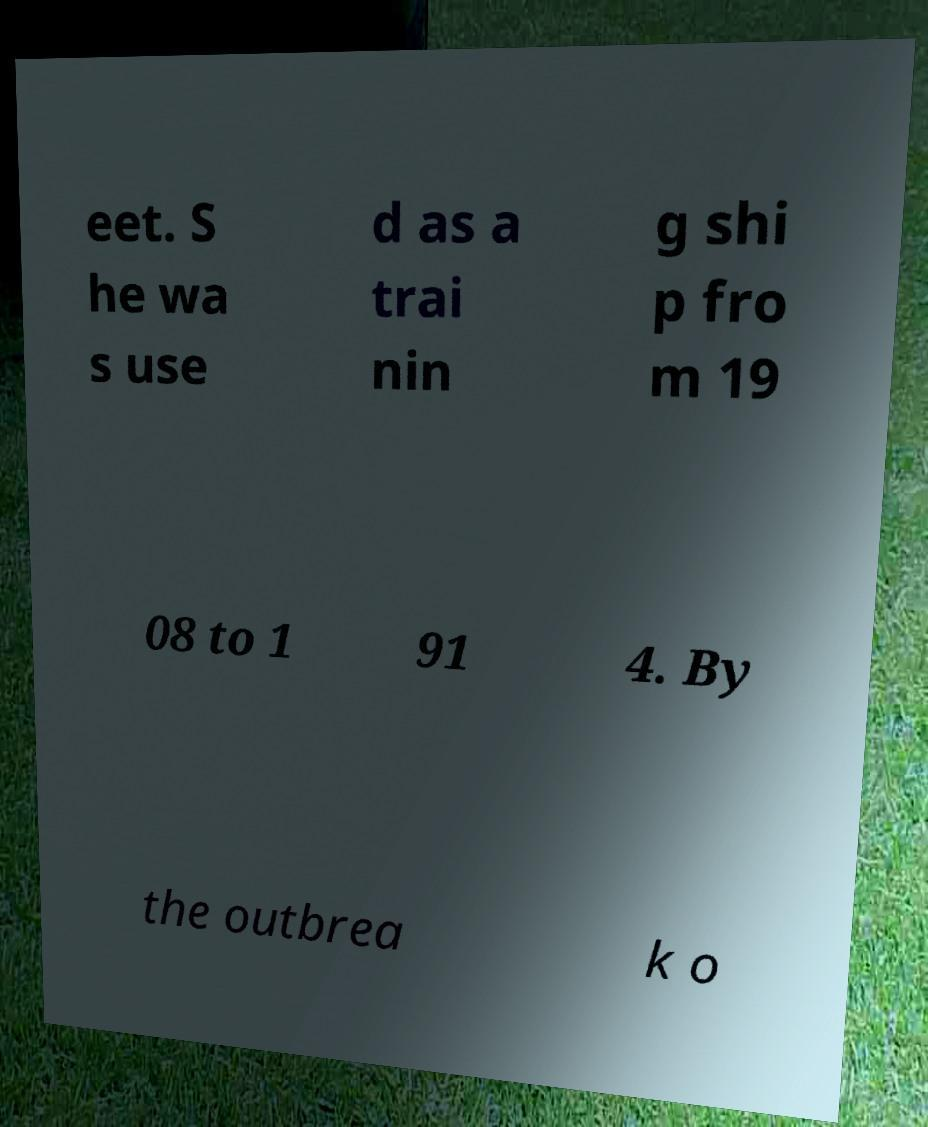Could you assist in decoding the text presented in this image and type it out clearly? eet. S he wa s use d as a trai nin g shi p fro m 19 08 to 1 91 4. By the outbrea k o 